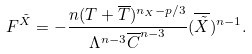<formula> <loc_0><loc_0><loc_500><loc_500>F ^ { \tilde { X } } = - \frac { n ( T + \overline { T } ) ^ { n _ { X } - p / 3 } } { \Lambda ^ { n - 3 } \overline { C } ^ { n - 3 } } ( \overline { \tilde { X } } ) ^ { n - 1 } .</formula> 